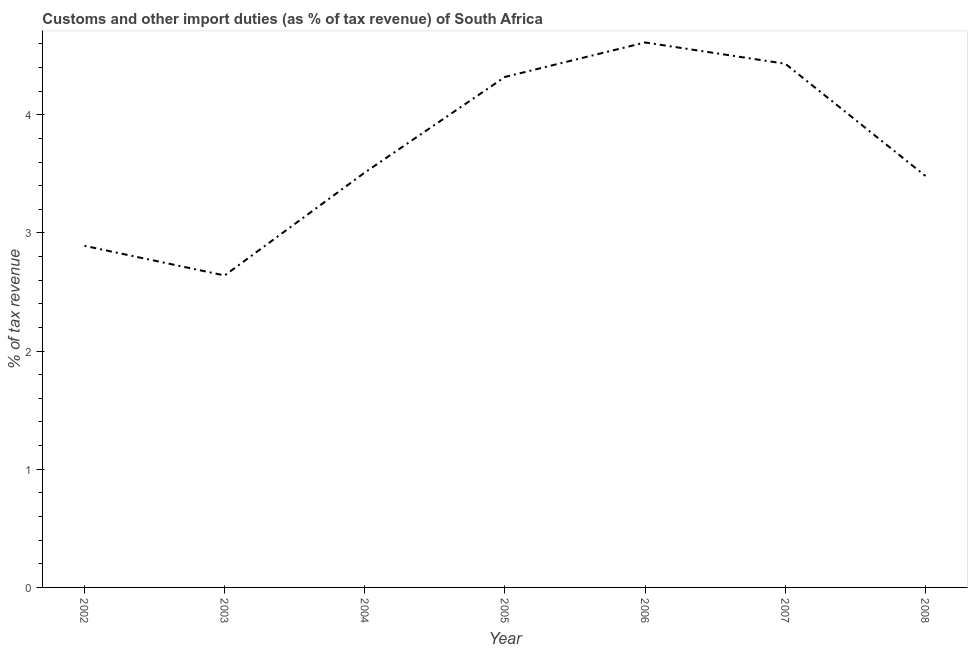What is the customs and other import duties in 2004?
Your answer should be very brief. 3.51. Across all years, what is the maximum customs and other import duties?
Give a very brief answer. 4.61. Across all years, what is the minimum customs and other import duties?
Keep it short and to the point. 2.64. In which year was the customs and other import duties maximum?
Give a very brief answer. 2006. In which year was the customs and other import duties minimum?
Provide a short and direct response. 2003. What is the sum of the customs and other import duties?
Offer a terse response. 25.89. What is the difference between the customs and other import duties in 2007 and 2008?
Keep it short and to the point. 0.95. What is the average customs and other import duties per year?
Your response must be concise. 3.7. What is the median customs and other import duties?
Your answer should be very brief. 3.51. In how many years, is the customs and other import duties greater than 2.6 %?
Give a very brief answer. 7. Do a majority of the years between 2003 and 2002 (inclusive) have customs and other import duties greater than 1.4 %?
Offer a very short reply. No. What is the ratio of the customs and other import duties in 2005 to that in 2007?
Keep it short and to the point. 0.97. Is the difference between the customs and other import duties in 2002 and 2008 greater than the difference between any two years?
Make the answer very short. No. What is the difference between the highest and the second highest customs and other import duties?
Ensure brevity in your answer.  0.18. What is the difference between the highest and the lowest customs and other import duties?
Provide a short and direct response. 1.97. How many lines are there?
Give a very brief answer. 1. How many years are there in the graph?
Provide a short and direct response. 7. What is the difference between two consecutive major ticks on the Y-axis?
Your response must be concise. 1. Are the values on the major ticks of Y-axis written in scientific E-notation?
Offer a terse response. No. Does the graph contain any zero values?
Make the answer very short. No. What is the title of the graph?
Offer a terse response. Customs and other import duties (as % of tax revenue) of South Africa. What is the label or title of the X-axis?
Your response must be concise. Year. What is the label or title of the Y-axis?
Keep it short and to the point. % of tax revenue. What is the % of tax revenue of 2002?
Offer a terse response. 2.89. What is the % of tax revenue of 2003?
Your answer should be very brief. 2.64. What is the % of tax revenue in 2004?
Provide a short and direct response. 3.51. What is the % of tax revenue of 2005?
Give a very brief answer. 4.32. What is the % of tax revenue in 2006?
Ensure brevity in your answer.  4.61. What is the % of tax revenue of 2007?
Your response must be concise. 4.43. What is the % of tax revenue of 2008?
Your answer should be very brief. 3.48. What is the difference between the % of tax revenue in 2002 and 2003?
Give a very brief answer. 0.25. What is the difference between the % of tax revenue in 2002 and 2004?
Your response must be concise. -0.62. What is the difference between the % of tax revenue in 2002 and 2005?
Your answer should be very brief. -1.43. What is the difference between the % of tax revenue in 2002 and 2006?
Provide a succinct answer. -1.72. What is the difference between the % of tax revenue in 2002 and 2007?
Offer a terse response. -1.54. What is the difference between the % of tax revenue in 2002 and 2008?
Make the answer very short. -0.59. What is the difference between the % of tax revenue in 2003 and 2004?
Offer a very short reply. -0.87. What is the difference between the % of tax revenue in 2003 and 2005?
Offer a terse response. -1.68. What is the difference between the % of tax revenue in 2003 and 2006?
Make the answer very short. -1.97. What is the difference between the % of tax revenue in 2003 and 2007?
Provide a short and direct response. -1.79. What is the difference between the % of tax revenue in 2003 and 2008?
Offer a terse response. -0.84. What is the difference between the % of tax revenue in 2004 and 2005?
Ensure brevity in your answer.  -0.81. What is the difference between the % of tax revenue in 2004 and 2006?
Provide a short and direct response. -1.1. What is the difference between the % of tax revenue in 2004 and 2007?
Your answer should be compact. -0.92. What is the difference between the % of tax revenue in 2004 and 2008?
Offer a very short reply. 0.03. What is the difference between the % of tax revenue in 2005 and 2006?
Your answer should be compact. -0.29. What is the difference between the % of tax revenue in 2005 and 2007?
Your response must be concise. -0.11. What is the difference between the % of tax revenue in 2005 and 2008?
Offer a terse response. 0.84. What is the difference between the % of tax revenue in 2006 and 2007?
Ensure brevity in your answer.  0.18. What is the difference between the % of tax revenue in 2006 and 2008?
Offer a very short reply. 1.13. What is the difference between the % of tax revenue in 2007 and 2008?
Your answer should be very brief. 0.95. What is the ratio of the % of tax revenue in 2002 to that in 2003?
Offer a terse response. 1.09. What is the ratio of the % of tax revenue in 2002 to that in 2004?
Your answer should be very brief. 0.82. What is the ratio of the % of tax revenue in 2002 to that in 2005?
Offer a very short reply. 0.67. What is the ratio of the % of tax revenue in 2002 to that in 2006?
Offer a terse response. 0.63. What is the ratio of the % of tax revenue in 2002 to that in 2007?
Provide a succinct answer. 0.65. What is the ratio of the % of tax revenue in 2002 to that in 2008?
Ensure brevity in your answer.  0.83. What is the ratio of the % of tax revenue in 2003 to that in 2004?
Your answer should be compact. 0.75. What is the ratio of the % of tax revenue in 2003 to that in 2005?
Provide a short and direct response. 0.61. What is the ratio of the % of tax revenue in 2003 to that in 2006?
Your answer should be very brief. 0.57. What is the ratio of the % of tax revenue in 2003 to that in 2007?
Provide a short and direct response. 0.6. What is the ratio of the % of tax revenue in 2003 to that in 2008?
Offer a very short reply. 0.76. What is the ratio of the % of tax revenue in 2004 to that in 2005?
Keep it short and to the point. 0.81. What is the ratio of the % of tax revenue in 2004 to that in 2006?
Provide a succinct answer. 0.76. What is the ratio of the % of tax revenue in 2004 to that in 2007?
Provide a short and direct response. 0.79. What is the ratio of the % of tax revenue in 2005 to that in 2006?
Your answer should be very brief. 0.94. What is the ratio of the % of tax revenue in 2005 to that in 2007?
Provide a short and direct response. 0.97. What is the ratio of the % of tax revenue in 2005 to that in 2008?
Your answer should be compact. 1.24. What is the ratio of the % of tax revenue in 2006 to that in 2007?
Ensure brevity in your answer.  1.04. What is the ratio of the % of tax revenue in 2006 to that in 2008?
Provide a short and direct response. 1.32. What is the ratio of the % of tax revenue in 2007 to that in 2008?
Your response must be concise. 1.27. 